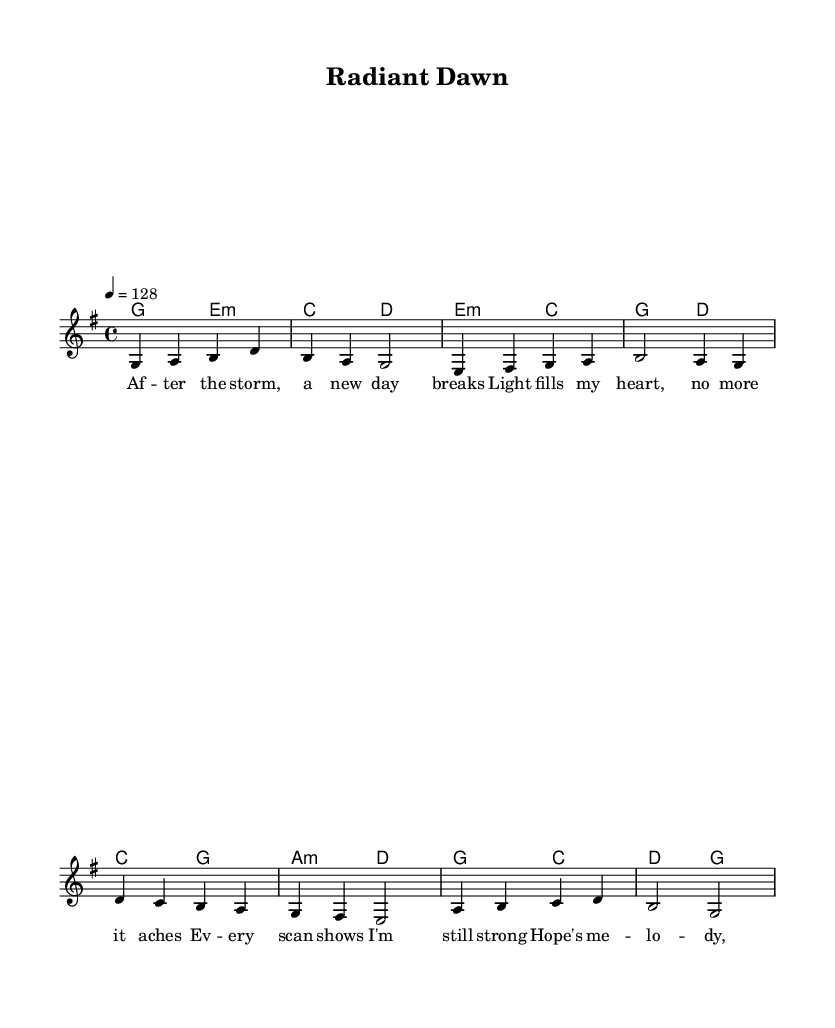What is the key signature of this music? The key signature is G major, which has one sharp (F#). This can be identified in the key signature section of the music, where the note F is elevated by a sharp symbol.
Answer: G major What is the time signature of the piece? The time signature is 4/4, which indicates that there are four beats in each measure, and the quarter note gets one beat. This is evident in the time signature notation found at the beginning of the score.
Answer: 4/4 What is the tempo marking indicated in the sheet music? The tempo marking is 128 beats per minute, which is noted in the tempo indication at the beginning of the score. This tells musicians how fast or slow to play the piece.
Answer: 128 How many measures are in the melody section? There are eight measures in the melody section. This can be determined by counting the vertical lines (bar lines) that divide the music into distinct sections, starting from the beginning until the end of the melody.
Answer: Eight What is the lyrical theme expressed in the verses? The lyrical theme is about hope and new beginnings, as indicated by the lines "After the storm, a new day breaks" and the overall sentiment conveyed in the lyrics. This revolves around resilience and positivity, fitting the theme of K-Pop songs.
Answer: Hope and new beginnings What type of harmony is primarily used in the piece? The harmony primarily used is diatonic harmony, characterized by chords that fit within the key of G major. This can be seen in the chord progression which aligns with notes from the G major scale.
Answer: Diatonic harmony Which musical tradition does the piece reflect? The piece reflects the K-Pop musical tradition, which is known for its upbeat melodies and themes of hope, as seen in both the musical score and lyrical content. K-Pop often revolves around relatable and uplifting themes.
Answer: K-Pop 